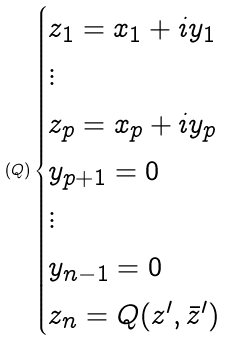Convert formula to latex. <formula><loc_0><loc_0><loc_500><loc_500>( Q ) \begin{cases} z _ { 1 } = x _ { 1 } + i y _ { 1 } \\ \vdots \\ z _ { p } = x _ { p } + i y _ { p } \\ y _ { p + 1 } = 0 \\ \vdots \\ y _ { n - 1 } = 0 \\ z _ { n } = Q ( z ^ { \prime } , \bar { z } ^ { \prime } ) \end{cases}</formula> 